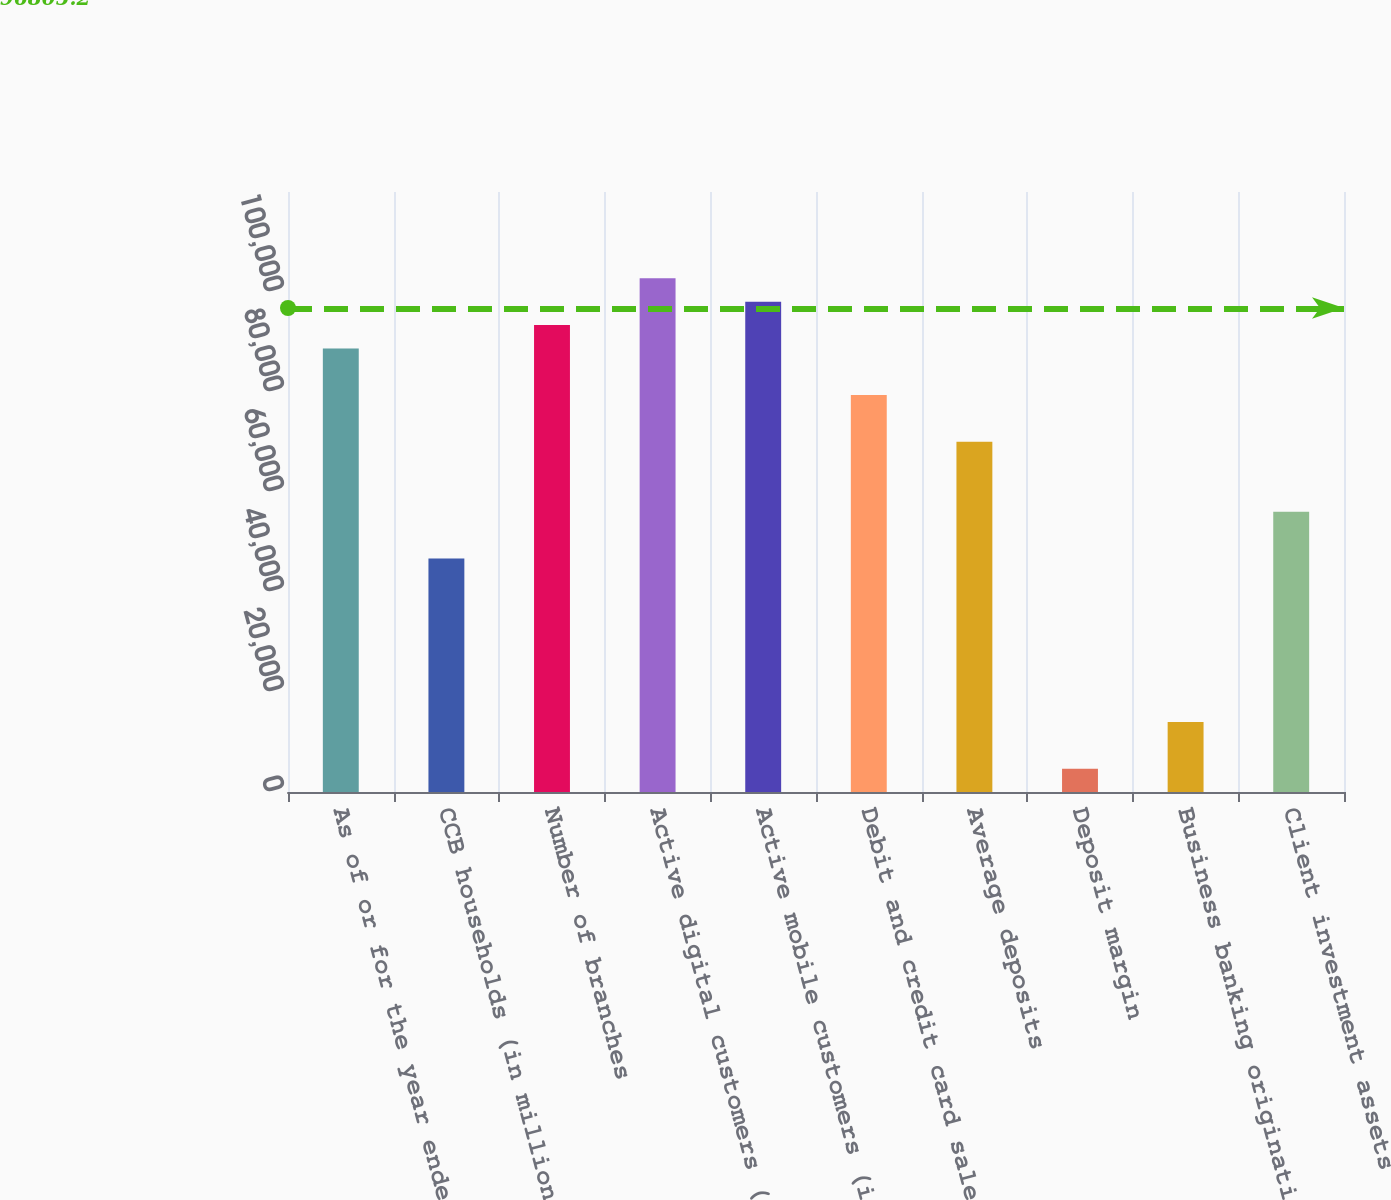Convert chart to OTSL. <chart><loc_0><loc_0><loc_500><loc_500><bar_chart><fcel>As of or for the year ended<fcel>CCB households (in millions)<fcel>Number of branches<fcel>Active digital customers (in<fcel>Active mobile customers (in<fcel>Debit and credit card sales<fcel>Average deposits<fcel>Deposit margin<fcel>Business banking origination<fcel>Client investment assets<nl><fcel>88717.6<fcel>46694<fcel>93386.9<fcel>102725<fcel>98056.2<fcel>79379<fcel>70040.4<fcel>4670.37<fcel>14009<fcel>56032.6<nl></chart> 